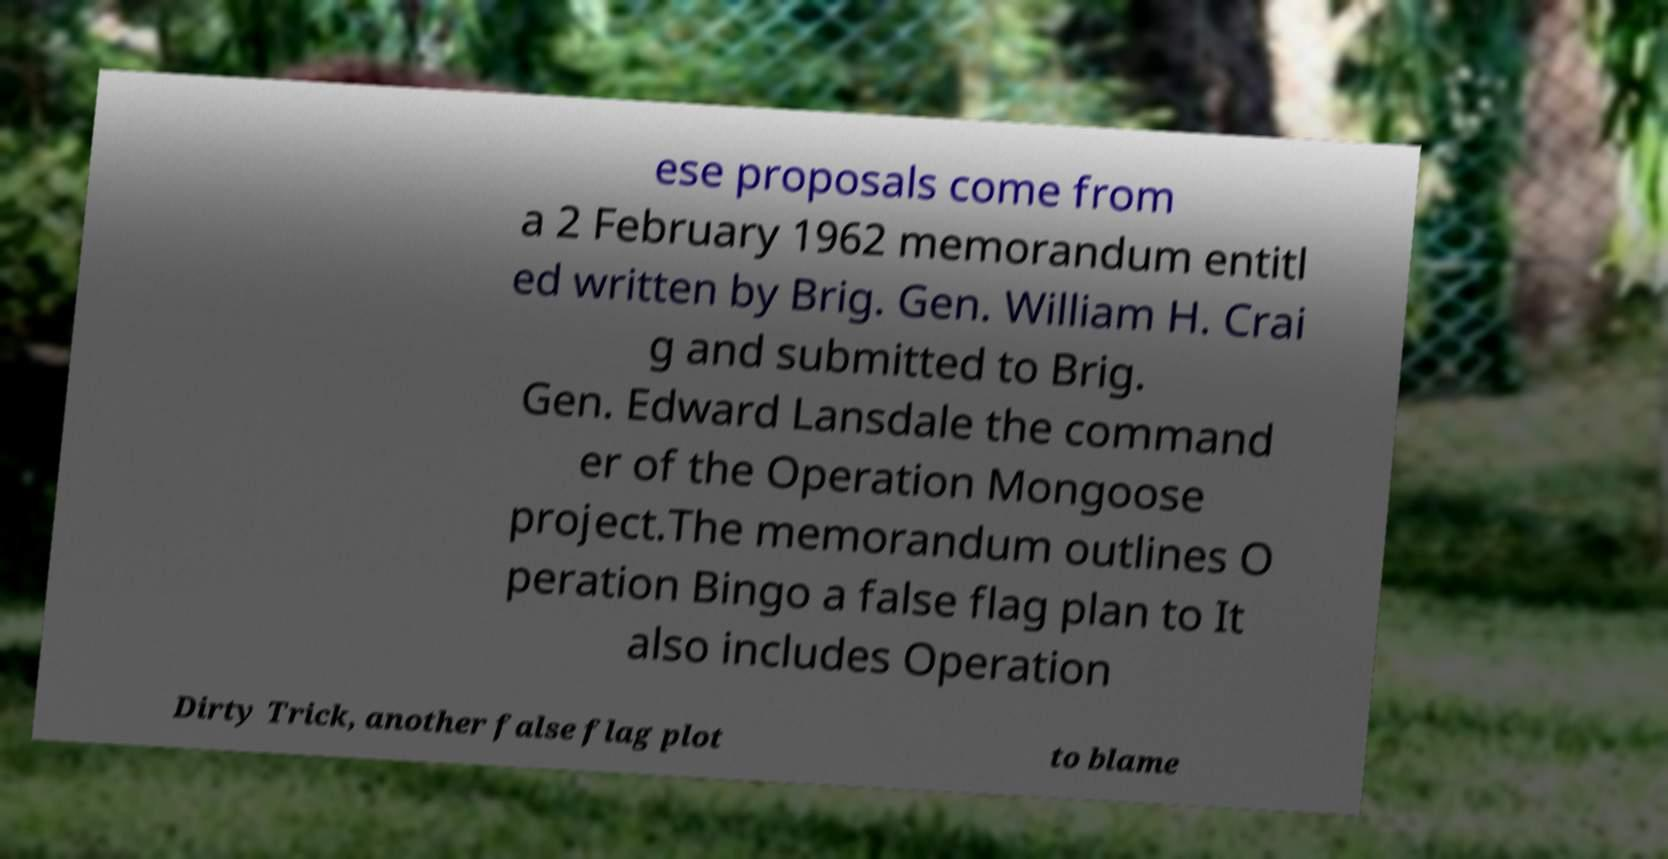I need the written content from this picture converted into text. Can you do that? ese proposals come from a 2 February 1962 memorandum entitl ed written by Brig. Gen. William H. Crai g and submitted to Brig. Gen. Edward Lansdale the command er of the Operation Mongoose project.The memorandum outlines O peration Bingo a false flag plan to It also includes Operation Dirty Trick, another false flag plot to blame 